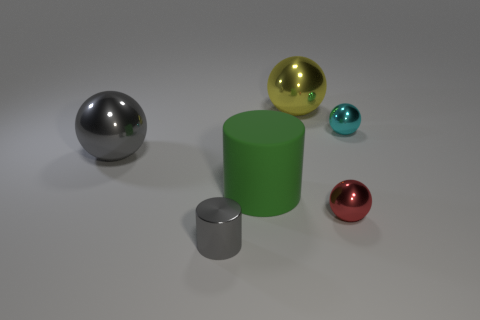Subtract all purple cylinders. Subtract all brown cubes. How many cylinders are left? 2 Add 3 large red objects. How many objects exist? 9 Subtract all balls. How many objects are left? 2 Subtract all gray balls. Subtract all big green cylinders. How many objects are left? 4 Add 2 small metallic cylinders. How many small metallic cylinders are left? 3 Add 3 yellow metal spheres. How many yellow metal spheres exist? 4 Subtract 0 gray cubes. How many objects are left? 6 